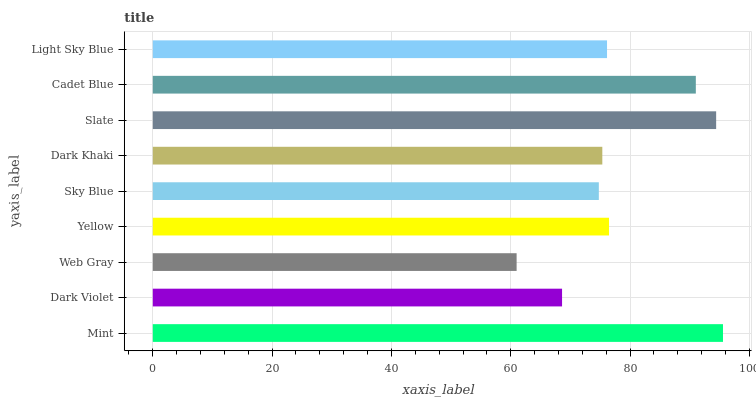Is Web Gray the minimum?
Answer yes or no. Yes. Is Mint the maximum?
Answer yes or no. Yes. Is Dark Violet the minimum?
Answer yes or no. No. Is Dark Violet the maximum?
Answer yes or no. No. Is Mint greater than Dark Violet?
Answer yes or no. Yes. Is Dark Violet less than Mint?
Answer yes or no. Yes. Is Dark Violet greater than Mint?
Answer yes or no. No. Is Mint less than Dark Violet?
Answer yes or no. No. Is Light Sky Blue the high median?
Answer yes or no. Yes. Is Light Sky Blue the low median?
Answer yes or no. Yes. Is Dark Khaki the high median?
Answer yes or no. No. Is Web Gray the low median?
Answer yes or no. No. 